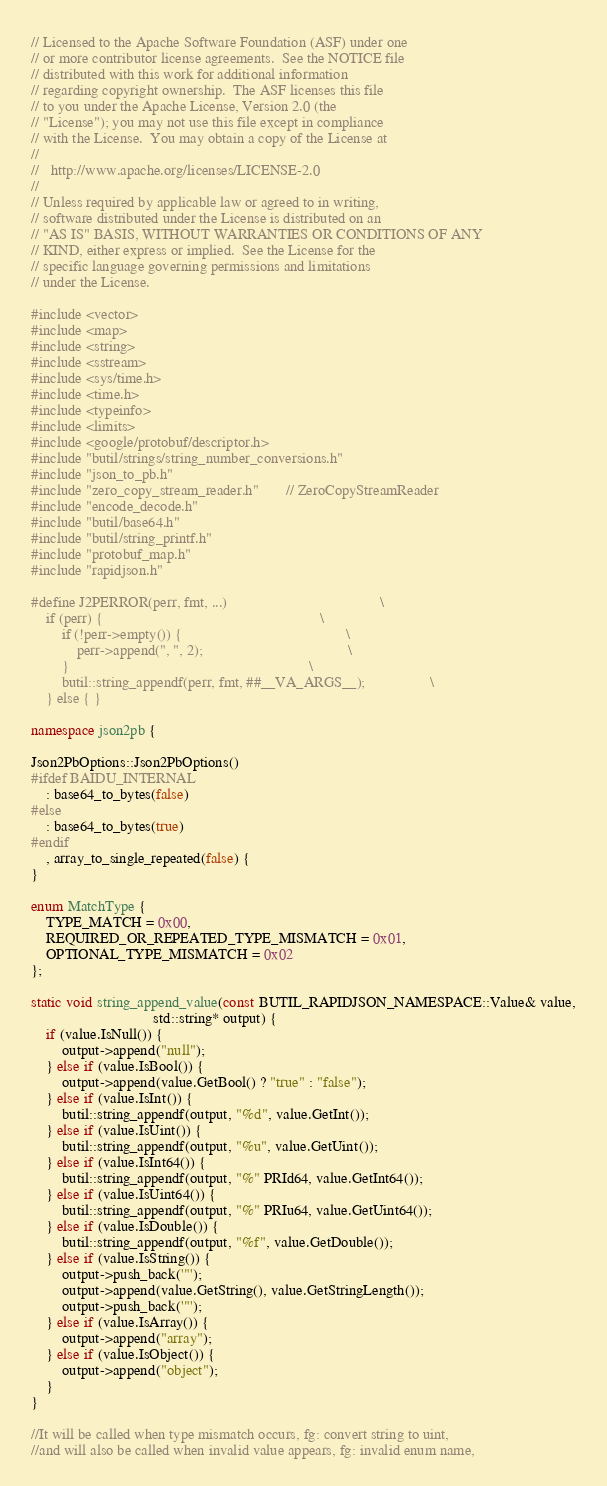Convert code to text. <code><loc_0><loc_0><loc_500><loc_500><_C++_>// Licensed to the Apache Software Foundation (ASF) under one
// or more contributor license agreements.  See the NOTICE file
// distributed with this work for additional information
// regarding copyright ownership.  The ASF licenses this file
// to you under the Apache License, Version 2.0 (the
// "License"); you may not use this file except in compliance
// with the License.  You may obtain a copy of the License at
//
//   http://www.apache.org/licenses/LICENSE-2.0
//
// Unless required by applicable law or agreed to in writing,
// software distributed under the License is distributed on an
// "AS IS" BASIS, WITHOUT WARRANTIES OR CONDITIONS OF ANY
// KIND, either express or implied.  See the License for the
// specific language governing permissions and limitations
// under the License.

#include <vector>
#include <map>
#include <string>
#include <sstream>
#include <sys/time.h>
#include <time.h>
#include <typeinfo>
#include <limits> 
#include <google/protobuf/descriptor.h>
#include "butil/strings/string_number_conversions.h"
#include "json_to_pb.h"
#include "zero_copy_stream_reader.h"       // ZeroCopyStreamReader
#include "encode_decode.h"
#include "butil/base64.h"
#include "butil/string_printf.h"
#include "protobuf_map.h"
#include "rapidjson.h"

#define J2PERROR(perr, fmt, ...)                                        \
    if (perr) {                                                         \
        if (!perr->empty()) {                                           \
            perr->append(", ", 2);                                      \
        }                                                               \
        butil::string_appendf(perr, fmt, ##__VA_ARGS__);                 \
    } else { }

namespace json2pb {

Json2PbOptions::Json2PbOptions()
#ifdef BAIDU_INTERNAL
    : base64_to_bytes(false)
#else
    : base64_to_bytes(true)
#endif
    , array_to_single_repeated(false) {
}

enum MatchType { 
    TYPE_MATCH = 0x00, 
    REQUIRED_OR_REPEATED_TYPE_MISMATCH = 0x01, 
    OPTIONAL_TYPE_MISMATCH = 0x02 
};
 
static void string_append_value(const BUTIL_RAPIDJSON_NAMESPACE::Value& value,
                                std::string* output) {
    if (value.IsNull()) {
        output->append("null");
    } else if (value.IsBool()) {
        output->append(value.GetBool() ? "true" : "false");
    } else if (value.IsInt()) {
        butil::string_appendf(output, "%d", value.GetInt());
    } else if (value.IsUint()) {
        butil::string_appendf(output, "%u", value.GetUint());
    } else if (value.IsInt64()) {
        butil::string_appendf(output, "%" PRId64, value.GetInt64());
    } else if (value.IsUint64()) {
        butil::string_appendf(output, "%" PRIu64, value.GetUint64());
    } else if (value.IsDouble()) {
        butil::string_appendf(output, "%f", value.GetDouble());
    } else if (value.IsString()) {
        output->push_back('"');
        output->append(value.GetString(), value.GetStringLength());
        output->push_back('"');
    } else if (value.IsArray()) {
        output->append("array");
    } else if (value.IsObject()) {
        output->append("object");
    }
}

//It will be called when type mismatch occurs, fg: convert string to uint, 
//and will also be called when invalid value appears, fg: invalid enum name,</code> 